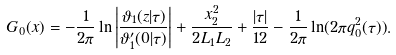<formula> <loc_0><loc_0><loc_500><loc_500>G _ { 0 } ( x ) = - \frac { 1 } { 2 \pi } \ln \left | \frac { \vartheta _ { 1 } ( z | \tau ) } { \vartheta ^ { \prime } _ { 1 } ( 0 | \tau ) } \right | + \frac { x _ { 2 } ^ { 2 } } { 2 L _ { 1 } L _ { 2 } } + \frac { | \tau | } { 1 2 } - \frac { 1 } { 2 \pi } \ln ( 2 \pi q _ { 0 } ^ { 2 } ( \tau ) ) .</formula> 